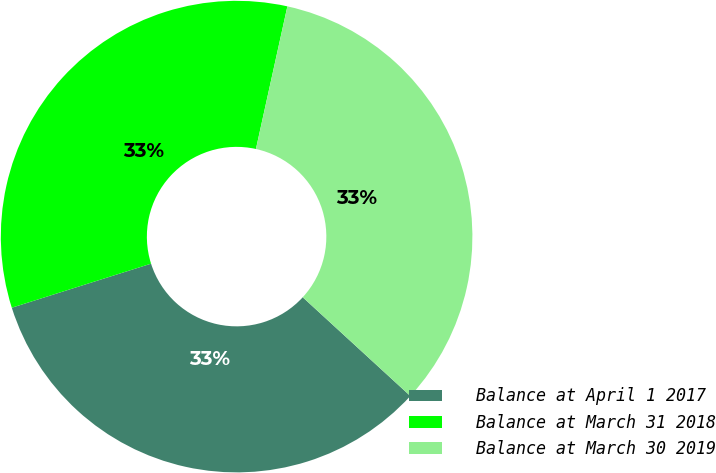<chart> <loc_0><loc_0><loc_500><loc_500><pie_chart><fcel>Balance at April 1 2017<fcel>Balance at March 31 2018<fcel>Balance at March 30 2019<nl><fcel>33.31%<fcel>33.33%<fcel>33.36%<nl></chart> 